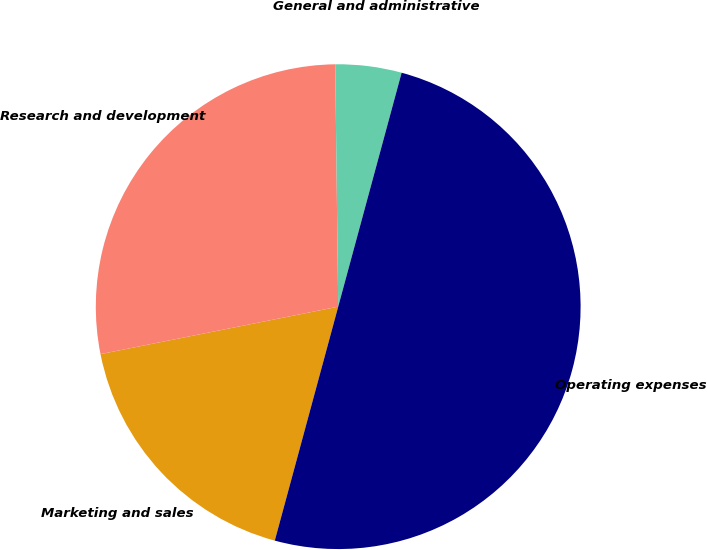<chart> <loc_0><loc_0><loc_500><loc_500><pie_chart><fcel>Marketing and sales<fcel>Research and development<fcel>General and administrative<fcel>Operating expenses<nl><fcel>17.65%<fcel>27.94%<fcel>4.41%<fcel>50.0%<nl></chart> 